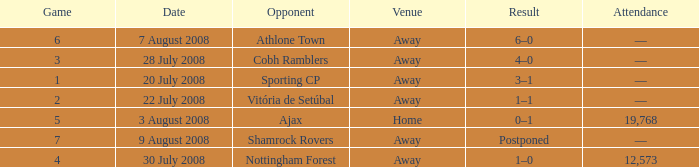What is the total game number with athlone town as the opponent? 1.0. 